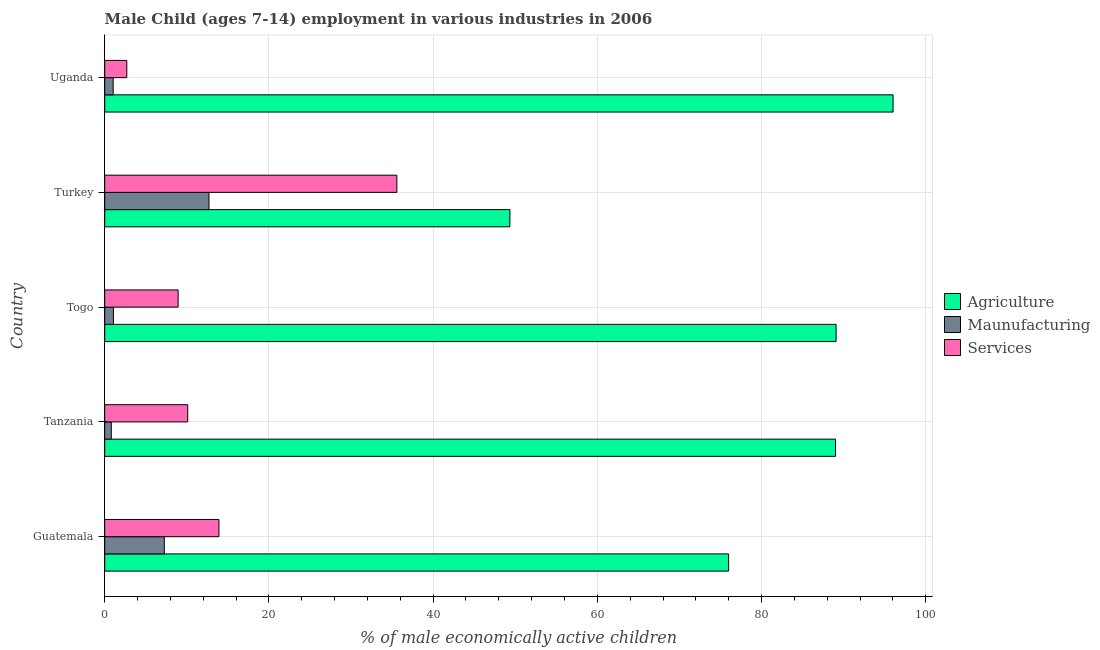How many different coloured bars are there?
Provide a succinct answer. 3. How many groups of bars are there?
Provide a short and direct response. 5. Are the number of bars on each tick of the Y-axis equal?
Provide a succinct answer. Yes. How many bars are there on the 5th tick from the top?
Give a very brief answer. 3. What is the label of the 1st group of bars from the top?
Your answer should be compact. Uganda. What is the percentage of economically active children in services in Uganda?
Offer a terse response. 2.69. Across all countries, what is the minimum percentage of economically active children in agriculture?
Your response must be concise. 49.35. In which country was the percentage of economically active children in manufacturing maximum?
Your response must be concise. Turkey. In which country was the percentage of economically active children in agriculture minimum?
Offer a very short reply. Turkey. What is the total percentage of economically active children in agriculture in the graph?
Offer a very short reply. 399.45. What is the difference between the percentage of economically active children in agriculture in Guatemala and that in Turkey?
Your answer should be compact. 26.64. What is the difference between the percentage of economically active children in services in Tanzania and the percentage of economically active children in agriculture in Turkey?
Your answer should be compact. -39.24. What is the average percentage of economically active children in agriculture per country?
Provide a short and direct response. 79.89. What is the difference between the percentage of economically active children in agriculture and percentage of economically active children in manufacturing in Turkey?
Your answer should be compact. 36.65. Is the difference between the percentage of economically active children in manufacturing in Guatemala and Uganda greater than the difference between the percentage of economically active children in agriculture in Guatemala and Uganda?
Provide a succinct answer. Yes. What is the difference between the highest and the second highest percentage of economically active children in manufacturing?
Your answer should be compact. 5.44. What is the difference between the highest and the lowest percentage of economically active children in manufacturing?
Your response must be concise. 11.9. In how many countries, is the percentage of economically active children in services greater than the average percentage of economically active children in services taken over all countries?
Your response must be concise. 1. Is the sum of the percentage of economically active children in agriculture in Togo and Uganda greater than the maximum percentage of economically active children in services across all countries?
Give a very brief answer. Yes. What does the 3rd bar from the top in Tanzania represents?
Offer a very short reply. Agriculture. What does the 1st bar from the bottom in Togo represents?
Your answer should be compact. Agriculture. Are all the bars in the graph horizontal?
Your answer should be compact. Yes. How many countries are there in the graph?
Your answer should be compact. 5. What is the difference between two consecutive major ticks on the X-axis?
Ensure brevity in your answer.  20. Are the values on the major ticks of X-axis written in scientific E-notation?
Keep it short and to the point. No. How many legend labels are there?
Make the answer very short. 3. What is the title of the graph?
Your response must be concise. Male Child (ages 7-14) employment in various industries in 2006. What is the label or title of the X-axis?
Your response must be concise. % of male economically active children. What is the label or title of the Y-axis?
Offer a terse response. Country. What is the % of male economically active children of Agriculture in Guatemala?
Your response must be concise. 75.99. What is the % of male economically active children of Maunufacturing in Guatemala?
Offer a terse response. 7.26. What is the % of male economically active children of Services in Guatemala?
Ensure brevity in your answer.  13.91. What is the % of male economically active children in Agriculture in Tanzania?
Your answer should be compact. 89.01. What is the % of male economically active children of Maunufacturing in Tanzania?
Offer a very short reply. 0.8. What is the % of male economically active children of Services in Tanzania?
Give a very brief answer. 10.11. What is the % of male economically active children of Agriculture in Togo?
Ensure brevity in your answer.  89.08. What is the % of male economically active children of Maunufacturing in Togo?
Give a very brief answer. 1.06. What is the % of male economically active children of Services in Togo?
Your answer should be compact. 8.94. What is the % of male economically active children of Agriculture in Turkey?
Give a very brief answer. 49.35. What is the % of male economically active children in Services in Turkey?
Keep it short and to the point. 35.58. What is the % of male economically active children of Agriculture in Uganda?
Offer a very short reply. 96.02. What is the % of male economically active children of Maunufacturing in Uganda?
Offer a terse response. 1.03. What is the % of male economically active children of Services in Uganda?
Your answer should be very brief. 2.69. Across all countries, what is the maximum % of male economically active children of Agriculture?
Your response must be concise. 96.02. Across all countries, what is the maximum % of male economically active children in Maunufacturing?
Keep it short and to the point. 12.7. Across all countries, what is the maximum % of male economically active children of Services?
Your answer should be compact. 35.58. Across all countries, what is the minimum % of male economically active children of Agriculture?
Offer a very short reply. 49.35. Across all countries, what is the minimum % of male economically active children in Maunufacturing?
Give a very brief answer. 0.8. Across all countries, what is the minimum % of male economically active children in Services?
Ensure brevity in your answer.  2.69. What is the total % of male economically active children in Agriculture in the graph?
Your response must be concise. 399.45. What is the total % of male economically active children in Maunufacturing in the graph?
Your answer should be very brief. 22.85. What is the total % of male economically active children of Services in the graph?
Keep it short and to the point. 71.23. What is the difference between the % of male economically active children in Agriculture in Guatemala and that in Tanzania?
Offer a very short reply. -13.02. What is the difference between the % of male economically active children in Maunufacturing in Guatemala and that in Tanzania?
Your response must be concise. 6.46. What is the difference between the % of male economically active children of Agriculture in Guatemala and that in Togo?
Give a very brief answer. -13.09. What is the difference between the % of male economically active children in Maunufacturing in Guatemala and that in Togo?
Give a very brief answer. 6.2. What is the difference between the % of male economically active children of Services in Guatemala and that in Togo?
Provide a short and direct response. 4.97. What is the difference between the % of male economically active children of Agriculture in Guatemala and that in Turkey?
Your answer should be compact. 26.64. What is the difference between the % of male economically active children in Maunufacturing in Guatemala and that in Turkey?
Ensure brevity in your answer.  -5.44. What is the difference between the % of male economically active children of Services in Guatemala and that in Turkey?
Your answer should be compact. -21.67. What is the difference between the % of male economically active children of Agriculture in Guatemala and that in Uganda?
Give a very brief answer. -20.03. What is the difference between the % of male economically active children of Maunufacturing in Guatemala and that in Uganda?
Your response must be concise. 6.23. What is the difference between the % of male economically active children of Services in Guatemala and that in Uganda?
Give a very brief answer. 11.22. What is the difference between the % of male economically active children of Agriculture in Tanzania and that in Togo?
Your answer should be very brief. -0.07. What is the difference between the % of male economically active children of Maunufacturing in Tanzania and that in Togo?
Ensure brevity in your answer.  -0.26. What is the difference between the % of male economically active children in Services in Tanzania and that in Togo?
Your answer should be compact. 1.17. What is the difference between the % of male economically active children in Agriculture in Tanzania and that in Turkey?
Offer a terse response. 39.66. What is the difference between the % of male economically active children in Maunufacturing in Tanzania and that in Turkey?
Your answer should be very brief. -11.9. What is the difference between the % of male economically active children in Services in Tanzania and that in Turkey?
Provide a succinct answer. -25.47. What is the difference between the % of male economically active children in Agriculture in Tanzania and that in Uganda?
Offer a terse response. -7.01. What is the difference between the % of male economically active children in Maunufacturing in Tanzania and that in Uganda?
Make the answer very short. -0.23. What is the difference between the % of male economically active children in Services in Tanzania and that in Uganda?
Your answer should be compact. 7.42. What is the difference between the % of male economically active children of Agriculture in Togo and that in Turkey?
Keep it short and to the point. 39.73. What is the difference between the % of male economically active children in Maunufacturing in Togo and that in Turkey?
Offer a very short reply. -11.64. What is the difference between the % of male economically active children of Services in Togo and that in Turkey?
Your response must be concise. -26.64. What is the difference between the % of male economically active children of Agriculture in Togo and that in Uganda?
Your answer should be very brief. -6.94. What is the difference between the % of male economically active children in Maunufacturing in Togo and that in Uganda?
Offer a very short reply. 0.03. What is the difference between the % of male economically active children of Services in Togo and that in Uganda?
Offer a very short reply. 6.25. What is the difference between the % of male economically active children of Agriculture in Turkey and that in Uganda?
Offer a terse response. -46.67. What is the difference between the % of male economically active children in Maunufacturing in Turkey and that in Uganda?
Make the answer very short. 11.67. What is the difference between the % of male economically active children of Services in Turkey and that in Uganda?
Offer a very short reply. 32.89. What is the difference between the % of male economically active children of Agriculture in Guatemala and the % of male economically active children of Maunufacturing in Tanzania?
Your answer should be very brief. 75.19. What is the difference between the % of male economically active children of Agriculture in Guatemala and the % of male economically active children of Services in Tanzania?
Your response must be concise. 65.88. What is the difference between the % of male economically active children of Maunufacturing in Guatemala and the % of male economically active children of Services in Tanzania?
Your response must be concise. -2.85. What is the difference between the % of male economically active children in Agriculture in Guatemala and the % of male economically active children in Maunufacturing in Togo?
Your answer should be compact. 74.93. What is the difference between the % of male economically active children in Agriculture in Guatemala and the % of male economically active children in Services in Togo?
Make the answer very short. 67.05. What is the difference between the % of male economically active children in Maunufacturing in Guatemala and the % of male economically active children in Services in Togo?
Give a very brief answer. -1.68. What is the difference between the % of male economically active children of Agriculture in Guatemala and the % of male economically active children of Maunufacturing in Turkey?
Give a very brief answer. 63.29. What is the difference between the % of male economically active children in Agriculture in Guatemala and the % of male economically active children in Services in Turkey?
Your answer should be very brief. 40.41. What is the difference between the % of male economically active children of Maunufacturing in Guatemala and the % of male economically active children of Services in Turkey?
Your answer should be very brief. -28.32. What is the difference between the % of male economically active children of Agriculture in Guatemala and the % of male economically active children of Maunufacturing in Uganda?
Provide a succinct answer. 74.96. What is the difference between the % of male economically active children in Agriculture in Guatemala and the % of male economically active children in Services in Uganda?
Your response must be concise. 73.3. What is the difference between the % of male economically active children of Maunufacturing in Guatemala and the % of male economically active children of Services in Uganda?
Your answer should be very brief. 4.57. What is the difference between the % of male economically active children in Agriculture in Tanzania and the % of male economically active children in Maunufacturing in Togo?
Give a very brief answer. 87.95. What is the difference between the % of male economically active children of Agriculture in Tanzania and the % of male economically active children of Services in Togo?
Provide a succinct answer. 80.07. What is the difference between the % of male economically active children in Maunufacturing in Tanzania and the % of male economically active children in Services in Togo?
Your answer should be very brief. -8.14. What is the difference between the % of male economically active children in Agriculture in Tanzania and the % of male economically active children in Maunufacturing in Turkey?
Provide a succinct answer. 76.31. What is the difference between the % of male economically active children in Agriculture in Tanzania and the % of male economically active children in Services in Turkey?
Offer a very short reply. 53.43. What is the difference between the % of male economically active children in Maunufacturing in Tanzania and the % of male economically active children in Services in Turkey?
Give a very brief answer. -34.78. What is the difference between the % of male economically active children of Agriculture in Tanzania and the % of male economically active children of Maunufacturing in Uganda?
Ensure brevity in your answer.  87.98. What is the difference between the % of male economically active children of Agriculture in Tanzania and the % of male economically active children of Services in Uganda?
Your answer should be very brief. 86.32. What is the difference between the % of male economically active children in Maunufacturing in Tanzania and the % of male economically active children in Services in Uganda?
Offer a terse response. -1.89. What is the difference between the % of male economically active children of Agriculture in Togo and the % of male economically active children of Maunufacturing in Turkey?
Give a very brief answer. 76.38. What is the difference between the % of male economically active children of Agriculture in Togo and the % of male economically active children of Services in Turkey?
Provide a short and direct response. 53.5. What is the difference between the % of male economically active children in Maunufacturing in Togo and the % of male economically active children in Services in Turkey?
Provide a succinct answer. -34.52. What is the difference between the % of male economically active children in Agriculture in Togo and the % of male economically active children in Maunufacturing in Uganda?
Your response must be concise. 88.05. What is the difference between the % of male economically active children in Agriculture in Togo and the % of male economically active children in Services in Uganda?
Provide a short and direct response. 86.39. What is the difference between the % of male economically active children of Maunufacturing in Togo and the % of male economically active children of Services in Uganda?
Keep it short and to the point. -1.63. What is the difference between the % of male economically active children in Agriculture in Turkey and the % of male economically active children in Maunufacturing in Uganda?
Your response must be concise. 48.32. What is the difference between the % of male economically active children in Agriculture in Turkey and the % of male economically active children in Services in Uganda?
Provide a succinct answer. 46.66. What is the difference between the % of male economically active children in Maunufacturing in Turkey and the % of male economically active children in Services in Uganda?
Give a very brief answer. 10.01. What is the average % of male economically active children of Agriculture per country?
Your answer should be compact. 79.89. What is the average % of male economically active children in Maunufacturing per country?
Your response must be concise. 4.57. What is the average % of male economically active children in Services per country?
Provide a short and direct response. 14.25. What is the difference between the % of male economically active children in Agriculture and % of male economically active children in Maunufacturing in Guatemala?
Provide a succinct answer. 68.73. What is the difference between the % of male economically active children of Agriculture and % of male economically active children of Services in Guatemala?
Ensure brevity in your answer.  62.08. What is the difference between the % of male economically active children in Maunufacturing and % of male economically active children in Services in Guatemala?
Offer a very short reply. -6.65. What is the difference between the % of male economically active children in Agriculture and % of male economically active children in Maunufacturing in Tanzania?
Provide a short and direct response. 88.21. What is the difference between the % of male economically active children of Agriculture and % of male economically active children of Services in Tanzania?
Your answer should be very brief. 78.9. What is the difference between the % of male economically active children in Maunufacturing and % of male economically active children in Services in Tanzania?
Ensure brevity in your answer.  -9.31. What is the difference between the % of male economically active children in Agriculture and % of male economically active children in Maunufacturing in Togo?
Offer a very short reply. 88.02. What is the difference between the % of male economically active children in Agriculture and % of male economically active children in Services in Togo?
Ensure brevity in your answer.  80.14. What is the difference between the % of male economically active children of Maunufacturing and % of male economically active children of Services in Togo?
Offer a very short reply. -7.88. What is the difference between the % of male economically active children in Agriculture and % of male economically active children in Maunufacturing in Turkey?
Make the answer very short. 36.65. What is the difference between the % of male economically active children of Agriculture and % of male economically active children of Services in Turkey?
Keep it short and to the point. 13.77. What is the difference between the % of male economically active children of Maunufacturing and % of male economically active children of Services in Turkey?
Make the answer very short. -22.88. What is the difference between the % of male economically active children in Agriculture and % of male economically active children in Maunufacturing in Uganda?
Offer a terse response. 94.99. What is the difference between the % of male economically active children in Agriculture and % of male economically active children in Services in Uganda?
Keep it short and to the point. 93.33. What is the difference between the % of male economically active children of Maunufacturing and % of male economically active children of Services in Uganda?
Offer a terse response. -1.66. What is the ratio of the % of male economically active children of Agriculture in Guatemala to that in Tanzania?
Your answer should be very brief. 0.85. What is the ratio of the % of male economically active children of Maunufacturing in Guatemala to that in Tanzania?
Offer a very short reply. 9.07. What is the ratio of the % of male economically active children in Services in Guatemala to that in Tanzania?
Your answer should be very brief. 1.38. What is the ratio of the % of male economically active children of Agriculture in Guatemala to that in Togo?
Offer a terse response. 0.85. What is the ratio of the % of male economically active children in Maunufacturing in Guatemala to that in Togo?
Provide a short and direct response. 6.85. What is the ratio of the % of male economically active children in Services in Guatemala to that in Togo?
Offer a terse response. 1.56. What is the ratio of the % of male economically active children in Agriculture in Guatemala to that in Turkey?
Make the answer very short. 1.54. What is the ratio of the % of male economically active children of Maunufacturing in Guatemala to that in Turkey?
Your answer should be very brief. 0.57. What is the ratio of the % of male economically active children in Services in Guatemala to that in Turkey?
Offer a terse response. 0.39. What is the ratio of the % of male economically active children in Agriculture in Guatemala to that in Uganda?
Keep it short and to the point. 0.79. What is the ratio of the % of male economically active children of Maunufacturing in Guatemala to that in Uganda?
Your response must be concise. 7.05. What is the ratio of the % of male economically active children in Services in Guatemala to that in Uganda?
Provide a short and direct response. 5.17. What is the ratio of the % of male economically active children of Agriculture in Tanzania to that in Togo?
Offer a terse response. 1. What is the ratio of the % of male economically active children in Maunufacturing in Tanzania to that in Togo?
Your response must be concise. 0.75. What is the ratio of the % of male economically active children of Services in Tanzania to that in Togo?
Give a very brief answer. 1.13. What is the ratio of the % of male economically active children in Agriculture in Tanzania to that in Turkey?
Your answer should be very brief. 1.8. What is the ratio of the % of male economically active children of Maunufacturing in Tanzania to that in Turkey?
Keep it short and to the point. 0.06. What is the ratio of the % of male economically active children of Services in Tanzania to that in Turkey?
Your answer should be compact. 0.28. What is the ratio of the % of male economically active children of Agriculture in Tanzania to that in Uganda?
Provide a short and direct response. 0.93. What is the ratio of the % of male economically active children in Maunufacturing in Tanzania to that in Uganda?
Offer a very short reply. 0.78. What is the ratio of the % of male economically active children of Services in Tanzania to that in Uganda?
Offer a terse response. 3.76. What is the ratio of the % of male economically active children of Agriculture in Togo to that in Turkey?
Provide a succinct answer. 1.81. What is the ratio of the % of male economically active children in Maunufacturing in Togo to that in Turkey?
Your response must be concise. 0.08. What is the ratio of the % of male economically active children in Services in Togo to that in Turkey?
Give a very brief answer. 0.25. What is the ratio of the % of male economically active children of Agriculture in Togo to that in Uganda?
Ensure brevity in your answer.  0.93. What is the ratio of the % of male economically active children in Maunufacturing in Togo to that in Uganda?
Offer a very short reply. 1.03. What is the ratio of the % of male economically active children in Services in Togo to that in Uganda?
Keep it short and to the point. 3.32. What is the ratio of the % of male economically active children in Agriculture in Turkey to that in Uganda?
Ensure brevity in your answer.  0.51. What is the ratio of the % of male economically active children in Maunufacturing in Turkey to that in Uganda?
Keep it short and to the point. 12.33. What is the ratio of the % of male economically active children in Services in Turkey to that in Uganda?
Give a very brief answer. 13.23. What is the difference between the highest and the second highest % of male economically active children of Agriculture?
Give a very brief answer. 6.94. What is the difference between the highest and the second highest % of male economically active children in Maunufacturing?
Ensure brevity in your answer.  5.44. What is the difference between the highest and the second highest % of male economically active children in Services?
Your answer should be compact. 21.67. What is the difference between the highest and the lowest % of male economically active children of Agriculture?
Provide a short and direct response. 46.67. What is the difference between the highest and the lowest % of male economically active children of Maunufacturing?
Your response must be concise. 11.9. What is the difference between the highest and the lowest % of male economically active children in Services?
Offer a very short reply. 32.89. 